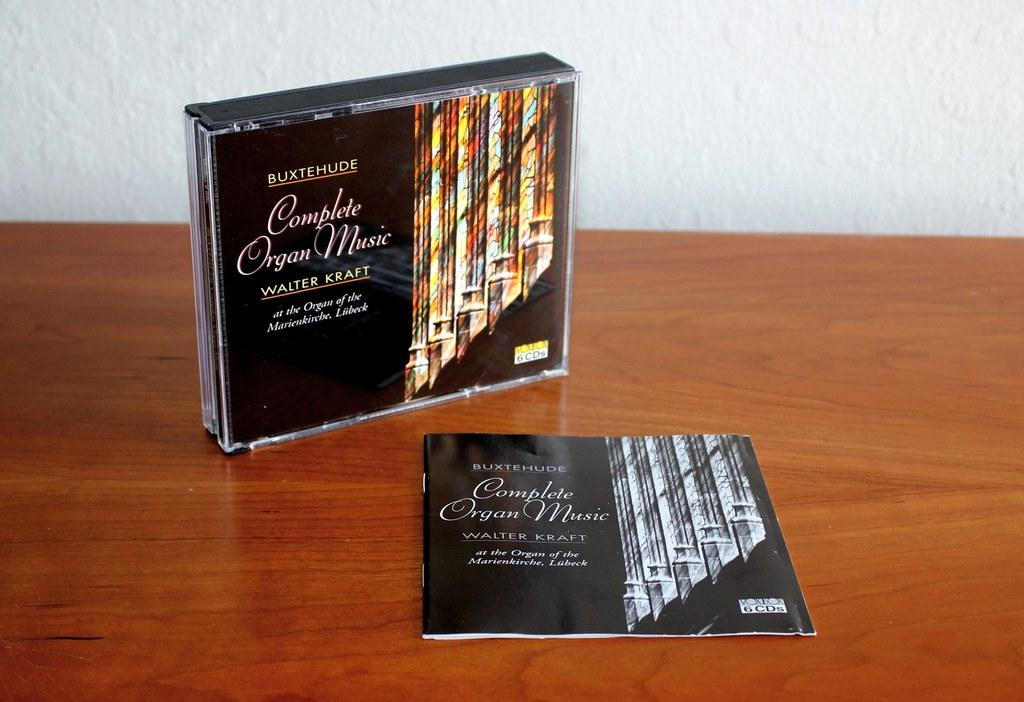Provide a one-sentence caption for the provided image. A cd case with the name Complete Organ Music on it. 